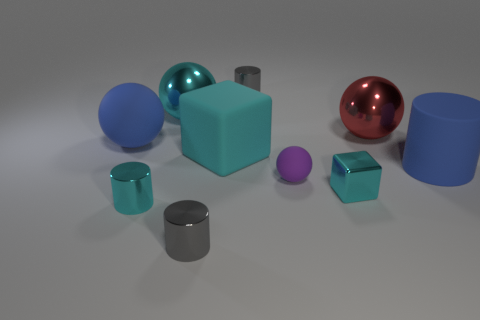What number of things are either small balls that are to the right of the big cyan metal thing or cylinders? In the image, there are two small balls situated to the right of the large cyan block, and there are three cylinders present in total. This makes for a combined count of five objects that fit the criteria. 